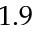<formula> <loc_0><loc_0><loc_500><loc_500>1 . 9</formula> 